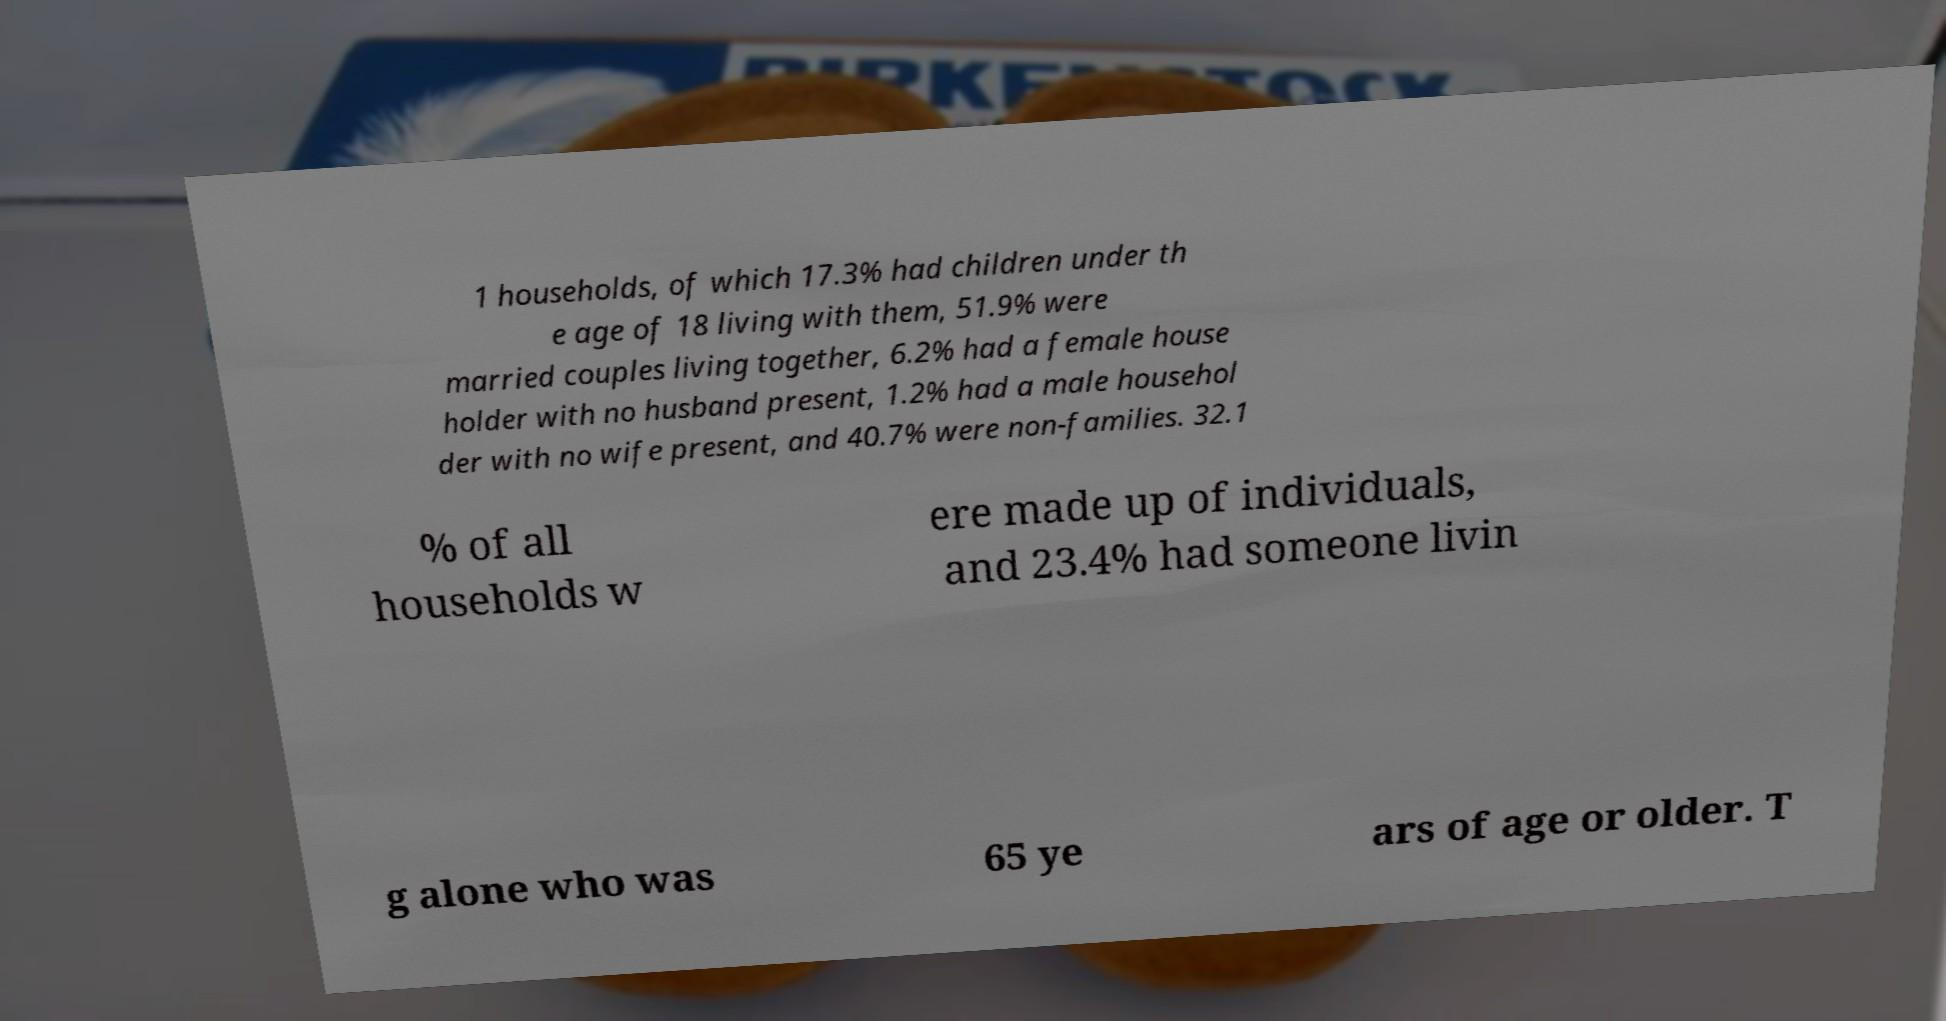For documentation purposes, I need the text within this image transcribed. Could you provide that? 1 households, of which 17.3% had children under th e age of 18 living with them, 51.9% were married couples living together, 6.2% had a female house holder with no husband present, 1.2% had a male househol der with no wife present, and 40.7% were non-families. 32.1 % of all households w ere made up of individuals, and 23.4% had someone livin g alone who was 65 ye ars of age or older. T 